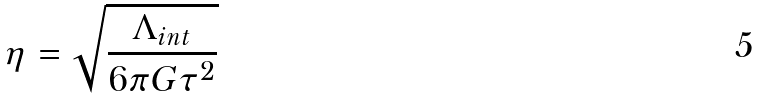<formula> <loc_0><loc_0><loc_500><loc_500>\eta = \sqrt { \frac { \Lambda _ { i n t } } { 6 \pi G \tau ^ { 2 } } }</formula> 